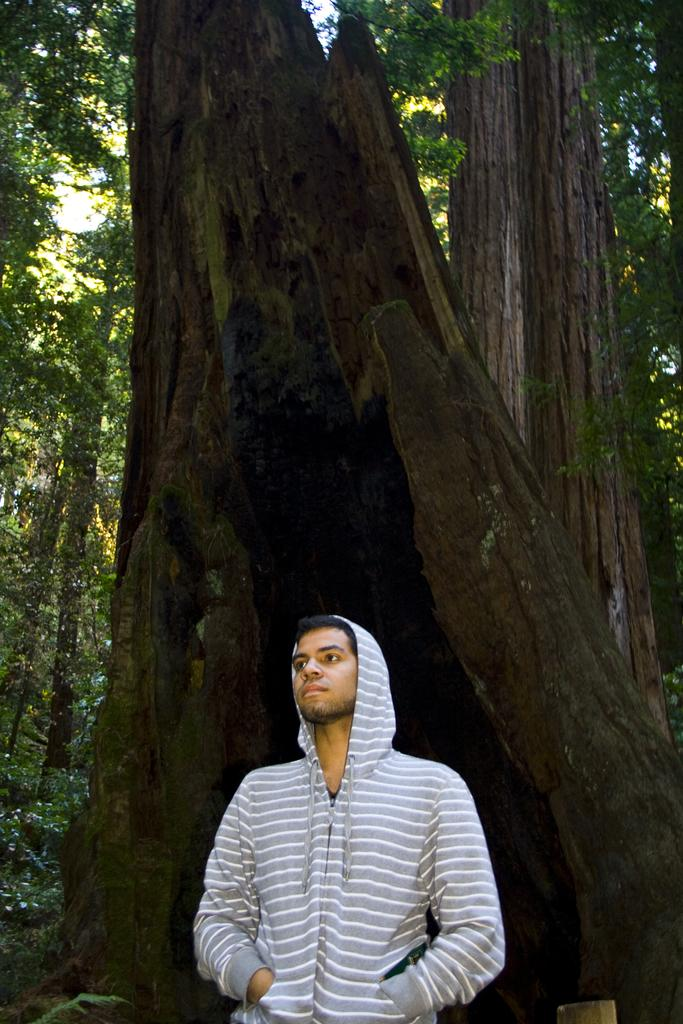Who or what is present in the image? There is a person in the image. What is the person wearing? The person is wearing a t-shirt. What is the person's posture in the image? The person is standing. What can be seen in the background of the image? There are trees in the background of the image. What is the color of the leaves on the trees? The trees have green leaves. What type of riddle can be seen written on the person's t-shirt in the image? There is no riddle visible on the person's t-shirt in the image. Can you spot a rabbit hiding among the trees in the background? There is no rabbit present in the image; only trees with green leaves are visible in the background. 